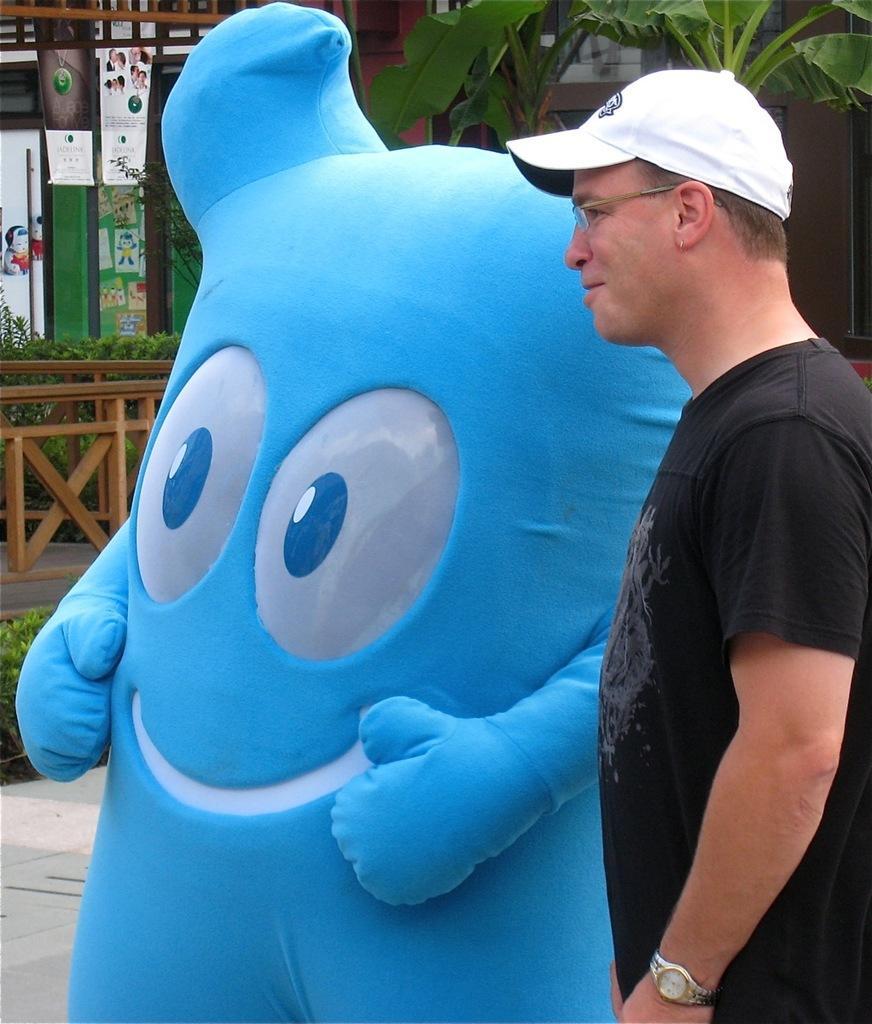Describe this image in one or two sentences. In this image, there is a person wearing clothes and standing beside the clown. This person is wearing spectacles and cap. There is a tree in the top right of the image. 